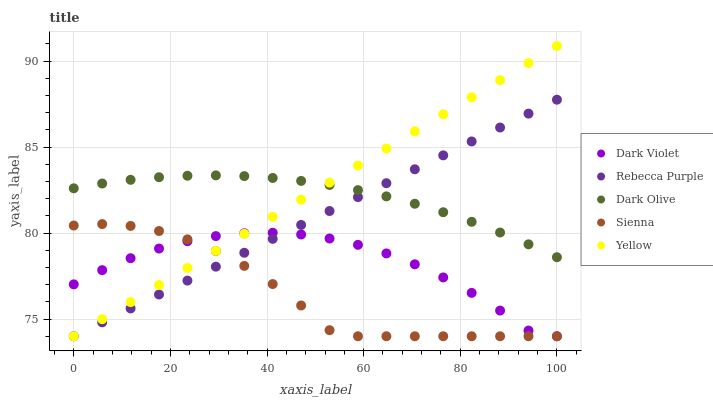Does Sienna have the minimum area under the curve?
Answer yes or no. Yes. Does Yellow have the maximum area under the curve?
Answer yes or no. Yes. Does Dark Olive have the minimum area under the curve?
Answer yes or no. No. Does Dark Olive have the maximum area under the curve?
Answer yes or no. No. Is Rebecca Purple the smoothest?
Answer yes or no. Yes. Is Sienna the roughest?
Answer yes or no. Yes. Is Dark Olive the smoothest?
Answer yes or no. No. Is Dark Olive the roughest?
Answer yes or no. No. Does Sienna have the lowest value?
Answer yes or no. Yes. Does Dark Olive have the lowest value?
Answer yes or no. No. Does Yellow have the highest value?
Answer yes or no. Yes. Does Dark Olive have the highest value?
Answer yes or no. No. Is Dark Violet less than Dark Olive?
Answer yes or no. Yes. Is Dark Olive greater than Sienna?
Answer yes or no. Yes. Does Dark Violet intersect Rebecca Purple?
Answer yes or no. Yes. Is Dark Violet less than Rebecca Purple?
Answer yes or no. No. Is Dark Violet greater than Rebecca Purple?
Answer yes or no. No. Does Dark Violet intersect Dark Olive?
Answer yes or no. No. 